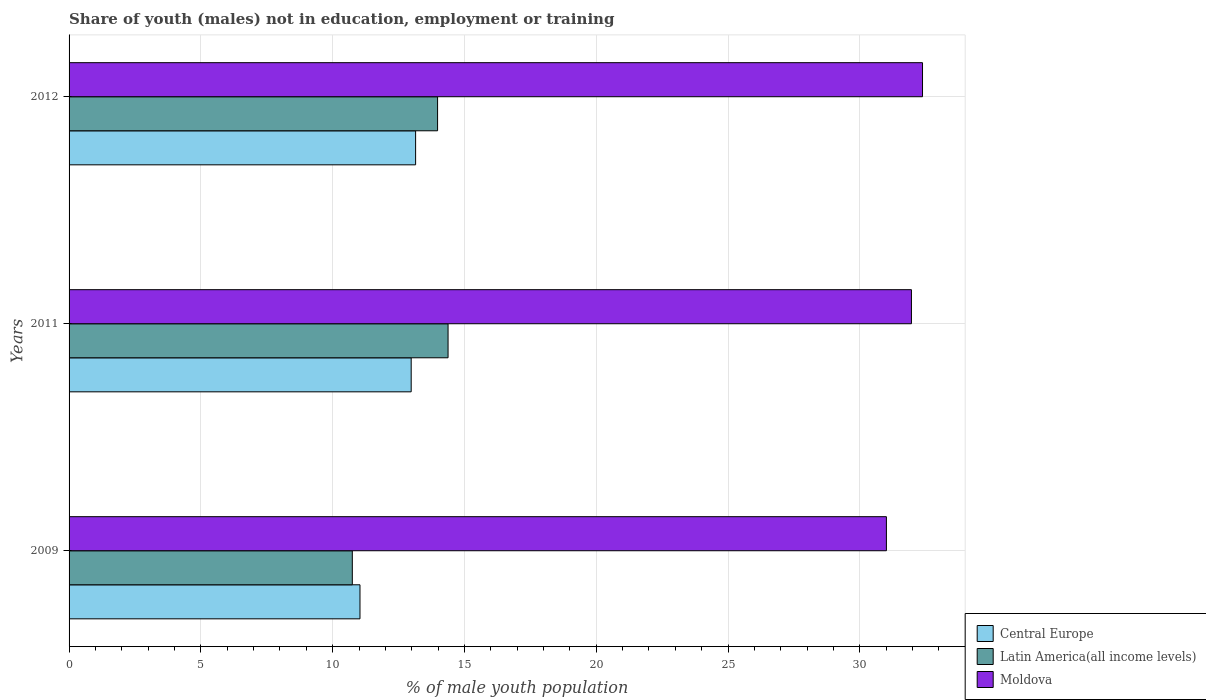How many different coloured bars are there?
Your response must be concise. 3. Are the number of bars on each tick of the Y-axis equal?
Your answer should be compact. Yes. How many bars are there on the 2nd tick from the top?
Give a very brief answer. 3. How many bars are there on the 1st tick from the bottom?
Your answer should be very brief. 3. What is the label of the 3rd group of bars from the top?
Make the answer very short. 2009. What is the percentage of unemployed males population in in Latin America(all income levels) in 2012?
Ensure brevity in your answer.  13.98. Across all years, what is the maximum percentage of unemployed males population in in Latin America(all income levels)?
Provide a succinct answer. 14.38. Across all years, what is the minimum percentage of unemployed males population in in Latin America(all income levels)?
Keep it short and to the point. 10.75. What is the total percentage of unemployed males population in in Moldova in the graph?
Your response must be concise. 95.35. What is the difference between the percentage of unemployed males population in in Moldova in 2009 and that in 2011?
Ensure brevity in your answer.  -0.95. What is the difference between the percentage of unemployed males population in in Central Europe in 2009 and the percentage of unemployed males population in in Moldova in 2012?
Provide a succinct answer. -21.34. What is the average percentage of unemployed males population in in Latin America(all income levels) per year?
Keep it short and to the point. 13.04. In the year 2009, what is the difference between the percentage of unemployed males population in in Moldova and percentage of unemployed males population in in Latin America(all income levels)?
Keep it short and to the point. 20.26. In how many years, is the percentage of unemployed males population in in Central Europe greater than 9 %?
Your answer should be compact. 3. What is the ratio of the percentage of unemployed males population in in Latin America(all income levels) in 2009 to that in 2011?
Your response must be concise. 0.75. Is the difference between the percentage of unemployed males population in in Moldova in 2009 and 2012 greater than the difference between the percentage of unemployed males population in in Latin America(all income levels) in 2009 and 2012?
Provide a short and direct response. Yes. What is the difference between the highest and the second highest percentage of unemployed males population in in Central Europe?
Give a very brief answer. 0.17. What is the difference between the highest and the lowest percentage of unemployed males population in in Moldova?
Keep it short and to the point. 1.37. In how many years, is the percentage of unemployed males population in in Central Europe greater than the average percentage of unemployed males population in in Central Europe taken over all years?
Ensure brevity in your answer.  2. What does the 2nd bar from the top in 2009 represents?
Keep it short and to the point. Latin America(all income levels). What does the 2nd bar from the bottom in 2011 represents?
Keep it short and to the point. Latin America(all income levels). Is it the case that in every year, the sum of the percentage of unemployed males population in in Central Europe and percentage of unemployed males population in in Moldova is greater than the percentage of unemployed males population in in Latin America(all income levels)?
Offer a very short reply. Yes. Are all the bars in the graph horizontal?
Provide a short and direct response. Yes. Does the graph contain grids?
Ensure brevity in your answer.  Yes. How many legend labels are there?
Make the answer very short. 3. How are the legend labels stacked?
Make the answer very short. Vertical. What is the title of the graph?
Your answer should be very brief. Share of youth (males) not in education, employment or training. What is the label or title of the X-axis?
Ensure brevity in your answer.  % of male youth population. What is the % of male youth population in Central Europe in 2009?
Offer a terse response. 11.04. What is the % of male youth population in Latin America(all income levels) in 2009?
Your answer should be compact. 10.75. What is the % of male youth population of Moldova in 2009?
Make the answer very short. 31.01. What is the % of male youth population in Central Europe in 2011?
Your answer should be very brief. 12.98. What is the % of male youth population in Latin America(all income levels) in 2011?
Your answer should be very brief. 14.38. What is the % of male youth population in Moldova in 2011?
Keep it short and to the point. 31.96. What is the % of male youth population of Central Europe in 2012?
Make the answer very short. 13.15. What is the % of male youth population of Latin America(all income levels) in 2012?
Your answer should be very brief. 13.98. What is the % of male youth population of Moldova in 2012?
Give a very brief answer. 32.38. Across all years, what is the maximum % of male youth population in Central Europe?
Your answer should be compact. 13.15. Across all years, what is the maximum % of male youth population in Latin America(all income levels)?
Offer a terse response. 14.38. Across all years, what is the maximum % of male youth population of Moldova?
Keep it short and to the point. 32.38. Across all years, what is the minimum % of male youth population of Central Europe?
Keep it short and to the point. 11.04. Across all years, what is the minimum % of male youth population of Latin America(all income levels)?
Give a very brief answer. 10.75. Across all years, what is the minimum % of male youth population of Moldova?
Ensure brevity in your answer.  31.01. What is the total % of male youth population in Central Europe in the graph?
Make the answer very short. 37.17. What is the total % of male youth population in Latin America(all income levels) in the graph?
Provide a short and direct response. 39.11. What is the total % of male youth population of Moldova in the graph?
Ensure brevity in your answer.  95.35. What is the difference between the % of male youth population in Central Europe in 2009 and that in 2011?
Your answer should be very brief. -1.94. What is the difference between the % of male youth population of Latin America(all income levels) in 2009 and that in 2011?
Provide a short and direct response. -3.63. What is the difference between the % of male youth population in Moldova in 2009 and that in 2011?
Make the answer very short. -0.95. What is the difference between the % of male youth population of Central Europe in 2009 and that in 2012?
Give a very brief answer. -2.11. What is the difference between the % of male youth population of Latin America(all income levels) in 2009 and that in 2012?
Give a very brief answer. -3.24. What is the difference between the % of male youth population of Moldova in 2009 and that in 2012?
Offer a very short reply. -1.37. What is the difference between the % of male youth population of Central Europe in 2011 and that in 2012?
Offer a very short reply. -0.17. What is the difference between the % of male youth population in Latin America(all income levels) in 2011 and that in 2012?
Offer a terse response. 0.4. What is the difference between the % of male youth population in Moldova in 2011 and that in 2012?
Ensure brevity in your answer.  -0.42. What is the difference between the % of male youth population in Central Europe in 2009 and the % of male youth population in Latin America(all income levels) in 2011?
Ensure brevity in your answer.  -3.34. What is the difference between the % of male youth population of Central Europe in 2009 and the % of male youth population of Moldova in 2011?
Your answer should be very brief. -20.92. What is the difference between the % of male youth population in Latin America(all income levels) in 2009 and the % of male youth population in Moldova in 2011?
Your response must be concise. -21.21. What is the difference between the % of male youth population in Central Europe in 2009 and the % of male youth population in Latin America(all income levels) in 2012?
Provide a succinct answer. -2.94. What is the difference between the % of male youth population in Central Europe in 2009 and the % of male youth population in Moldova in 2012?
Your response must be concise. -21.34. What is the difference between the % of male youth population in Latin America(all income levels) in 2009 and the % of male youth population in Moldova in 2012?
Your answer should be compact. -21.63. What is the difference between the % of male youth population in Central Europe in 2011 and the % of male youth population in Latin America(all income levels) in 2012?
Make the answer very short. -1. What is the difference between the % of male youth population in Central Europe in 2011 and the % of male youth population in Moldova in 2012?
Your answer should be very brief. -19.4. What is the difference between the % of male youth population in Latin America(all income levels) in 2011 and the % of male youth population in Moldova in 2012?
Provide a succinct answer. -18. What is the average % of male youth population of Central Europe per year?
Give a very brief answer. 12.39. What is the average % of male youth population of Latin America(all income levels) per year?
Keep it short and to the point. 13.04. What is the average % of male youth population of Moldova per year?
Keep it short and to the point. 31.78. In the year 2009, what is the difference between the % of male youth population in Central Europe and % of male youth population in Latin America(all income levels)?
Your answer should be compact. 0.29. In the year 2009, what is the difference between the % of male youth population in Central Europe and % of male youth population in Moldova?
Your answer should be compact. -19.97. In the year 2009, what is the difference between the % of male youth population of Latin America(all income levels) and % of male youth population of Moldova?
Make the answer very short. -20.26. In the year 2011, what is the difference between the % of male youth population in Central Europe and % of male youth population in Latin America(all income levels)?
Make the answer very short. -1.4. In the year 2011, what is the difference between the % of male youth population in Central Europe and % of male youth population in Moldova?
Make the answer very short. -18.98. In the year 2011, what is the difference between the % of male youth population in Latin America(all income levels) and % of male youth population in Moldova?
Offer a terse response. -17.58. In the year 2012, what is the difference between the % of male youth population of Central Europe and % of male youth population of Latin America(all income levels)?
Keep it short and to the point. -0.83. In the year 2012, what is the difference between the % of male youth population of Central Europe and % of male youth population of Moldova?
Provide a short and direct response. -19.23. In the year 2012, what is the difference between the % of male youth population in Latin America(all income levels) and % of male youth population in Moldova?
Your answer should be compact. -18.4. What is the ratio of the % of male youth population in Central Europe in 2009 to that in 2011?
Give a very brief answer. 0.85. What is the ratio of the % of male youth population in Latin America(all income levels) in 2009 to that in 2011?
Give a very brief answer. 0.75. What is the ratio of the % of male youth population in Moldova in 2009 to that in 2011?
Your answer should be very brief. 0.97. What is the ratio of the % of male youth population of Central Europe in 2009 to that in 2012?
Offer a terse response. 0.84. What is the ratio of the % of male youth population of Latin America(all income levels) in 2009 to that in 2012?
Offer a terse response. 0.77. What is the ratio of the % of male youth population in Moldova in 2009 to that in 2012?
Your answer should be compact. 0.96. What is the ratio of the % of male youth population in Central Europe in 2011 to that in 2012?
Give a very brief answer. 0.99. What is the ratio of the % of male youth population in Latin America(all income levels) in 2011 to that in 2012?
Ensure brevity in your answer.  1.03. What is the difference between the highest and the second highest % of male youth population of Central Europe?
Ensure brevity in your answer.  0.17. What is the difference between the highest and the second highest % of male youth population in Latin America(all income levels)?
Make the answer very short. 0.4. What is the difference between the highest and the second highest % of male youth population of Moldova?
Provide a succinct answer. 0.42. What is the difference between the highest and the lowest % of male youth population in Central Europe?
Give a very brief answer. 2.11. What is the difference between the highest and the lowest % of male youth population of Latin America(all income levels)?
Offer a very short reply. 3.63. What is the difference between the highest and the lowest % of male youth population in Moldova?
Your answer should be compact. 1.37. 